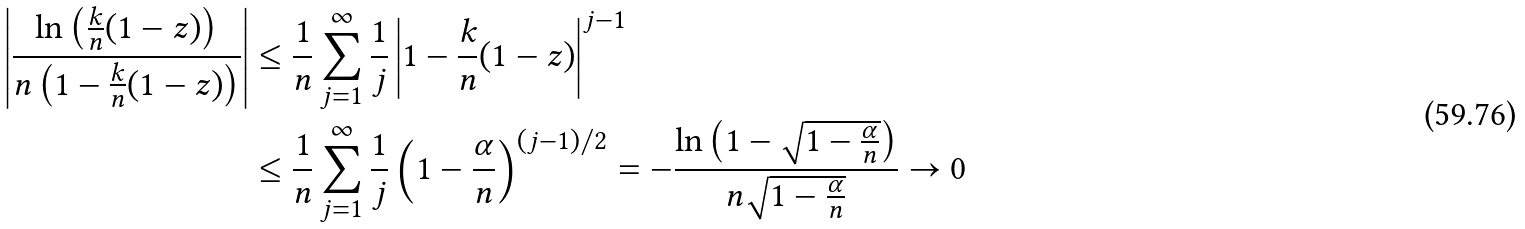Convert formula to latex. <formula><loc_0><loc_0><loc_500><loc_500>\left | \frac { \ln \left ( \frac { k } { n } ( 1 - z ) \right ) } { n \left ( 1 - \frac { k } { n } ( 1 - z ) \right ) } \right | & \leq \frac { 1 } { n } \sum _ { j = 1 } ^ { \infty } \frac { 1 } { j } \left | 1 - \frac { k } { n } ( 1 - z ) \right | ^ { j - 1 } \\ & \leq \frac { 1 } { n } \sum _ { j = 1 } ^ { \infty } \frac { 1 } { j } \left ( 1 - \frac { \alpha } { n } \right ) ^ { ( j - 1 ) / 2 } = - \frac { \ln \left ( 1 - \sqrt { 1 - \frac { \alpha } { n } } \right ) } { n \sqrt { 1 - \frac { \alpha } { n } } } \to 0</formula> 